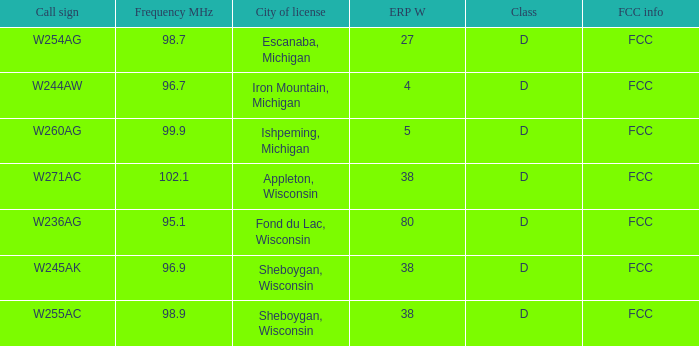What was the group for appleton, wisconsin? D. 